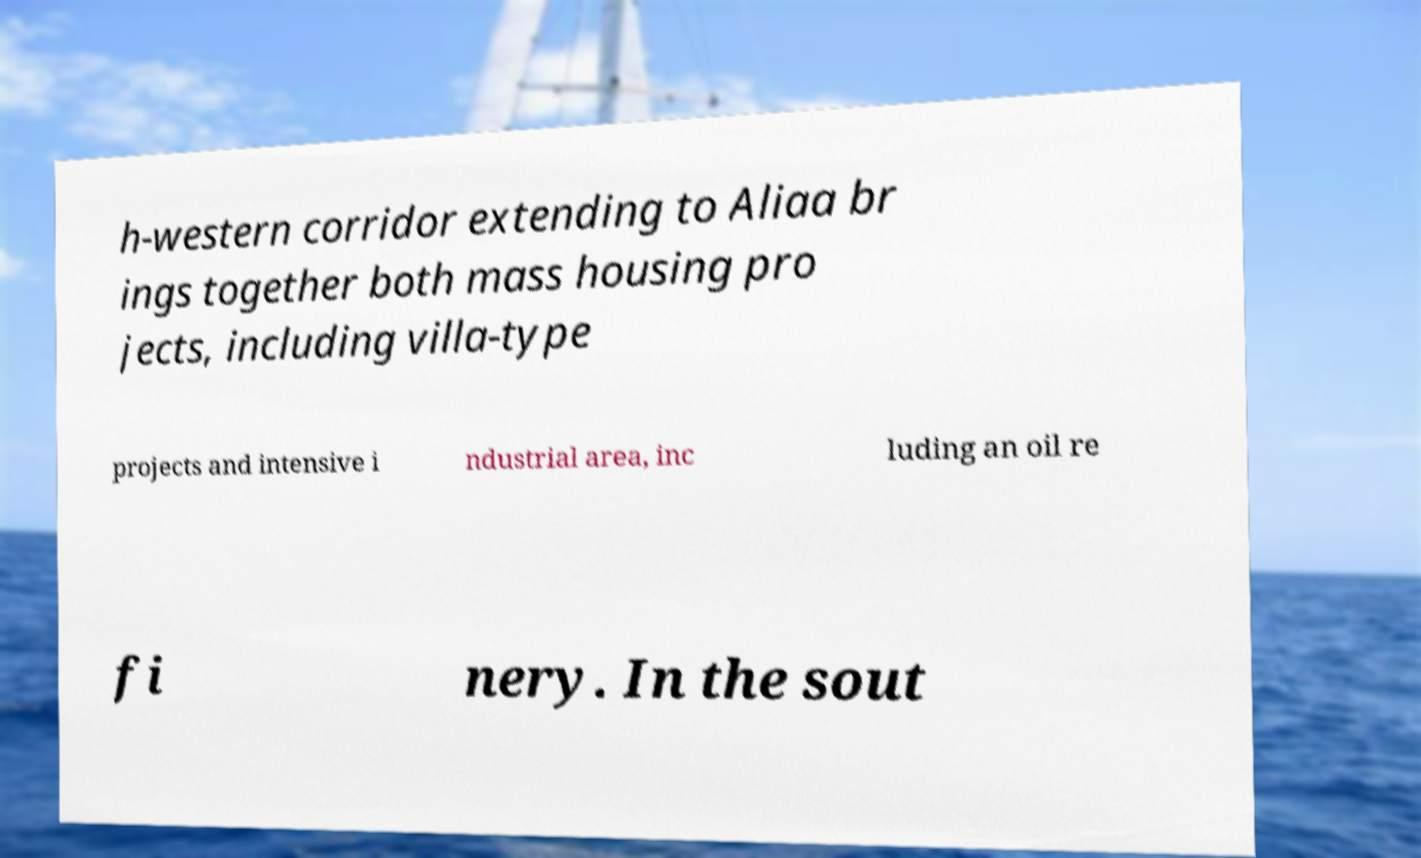I need the written content from this picture converted into text. Can you do that? h-western corridor extending to Aliaa br ings together both mass housing pro jects, including villa-type projects and intensive i ndustrial area, inc luding an oil re fi nery. In the sout 